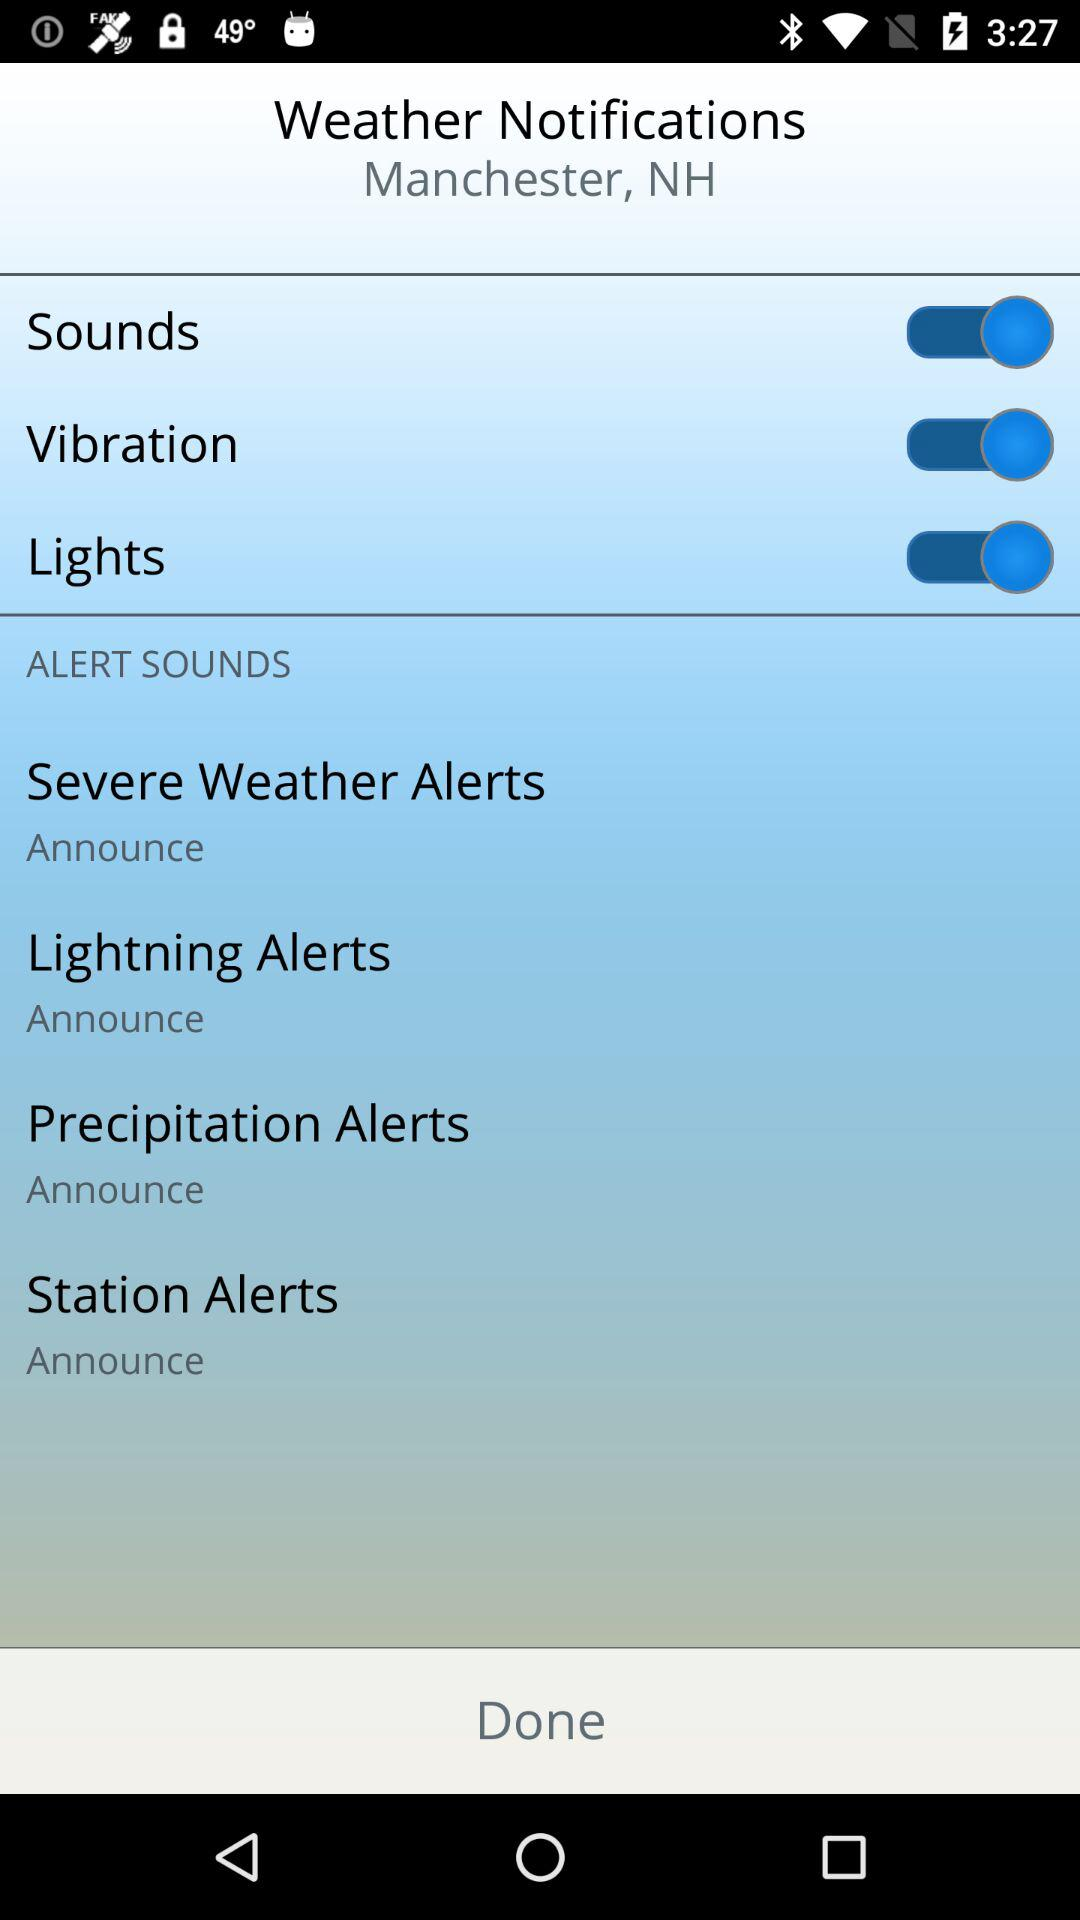What is the setting for "Station Alerts"? The setting is "Announce". 